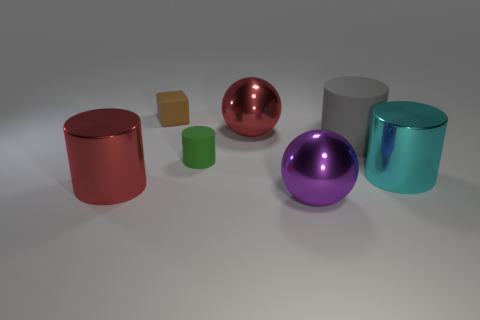Subtract all green cylinders. How many cylinders are left? 3 Subtract 1 cylinders. How many cylinders are left? 3 Subtract all green cylinders. How many cylinders are left? 3 Subtract all purple cylinders. Subtract all gray spheres. How many cylinders are left? 4 Subtract all cylinders. How many objects are left? 3 Add 1 green objects. How many objects exist? 8 Add 1 small green shiny objects. How many small green shiny objects exist? 1 Subtract 0 purple blocks. How many objects are left? 7 Subtract all red things. Subtract all large gray matte cylinders. How many objects are left? 4 Add 5 red objects. How many red objects are left? 7 